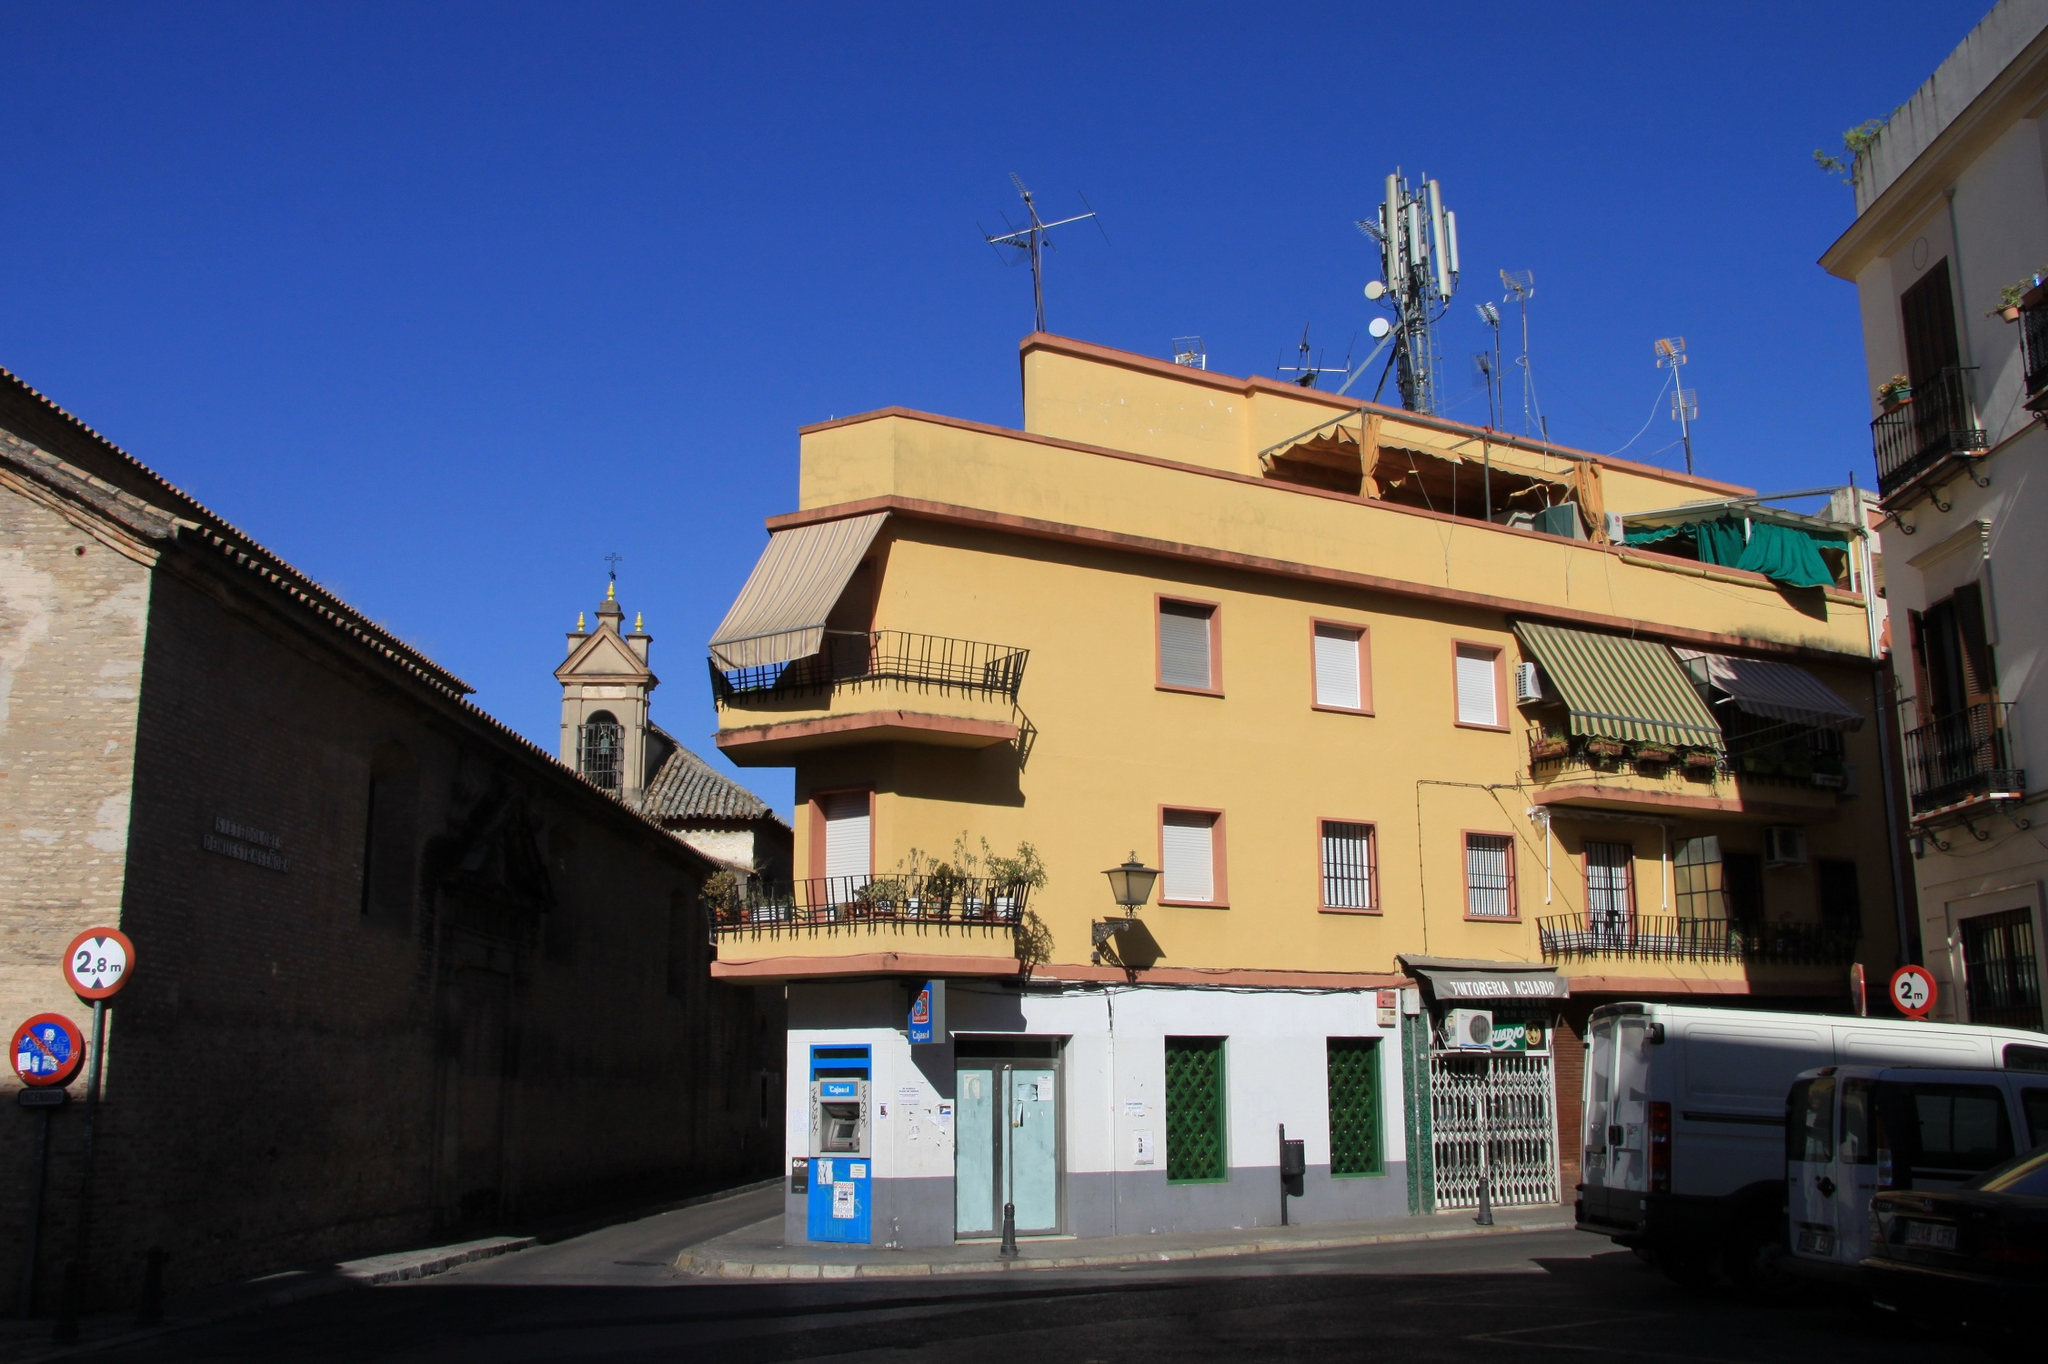Create a fantastical story set in this place. In the heart of an ancient European city, there stands a yellow building unlike any other. This building, known as the 'Golden Haven,' has a secret known to only a few: it is a portal to a magical world. Each night, as the city slumbers and the moonlight bathes the streets in silver, the green door of the 'Golden Haven' unlocks on its own, revealing a shimmering pathway. Those who dare to step through find themselves in an enchanted realm filled with luminescent flowers, talking animals, and lush forests. The bell tower of the adjacent church transforms, guiding travelers to mystical destinations while charming melodies fill the air. Here, time flows differently, allowing explorers to experience adventures that span weeks in the blink of an eye. Within this magical world, the yellow building's balconies overlook serene lakes, and its rooftops touch the sky, offering breathtaking views of celestial bodies dancing in the night. The plants that adorn the balconies are not just greenery, but whisper tales of ancient times and offer clues to hidden treasures. The residents of the 'Golden Haven' live dual lives, one in the bustling city and the other in this wondrous land. They are entrusted with the secrets of their extraordinary dwelling, ensuring that the magic of the 'Golden Haven' continues to thrive for generations to come. This building, a silent sentinel of dreams and reality, stands as a bridge between the mundane and the magical, forever a beacon of wonder and adventure. 